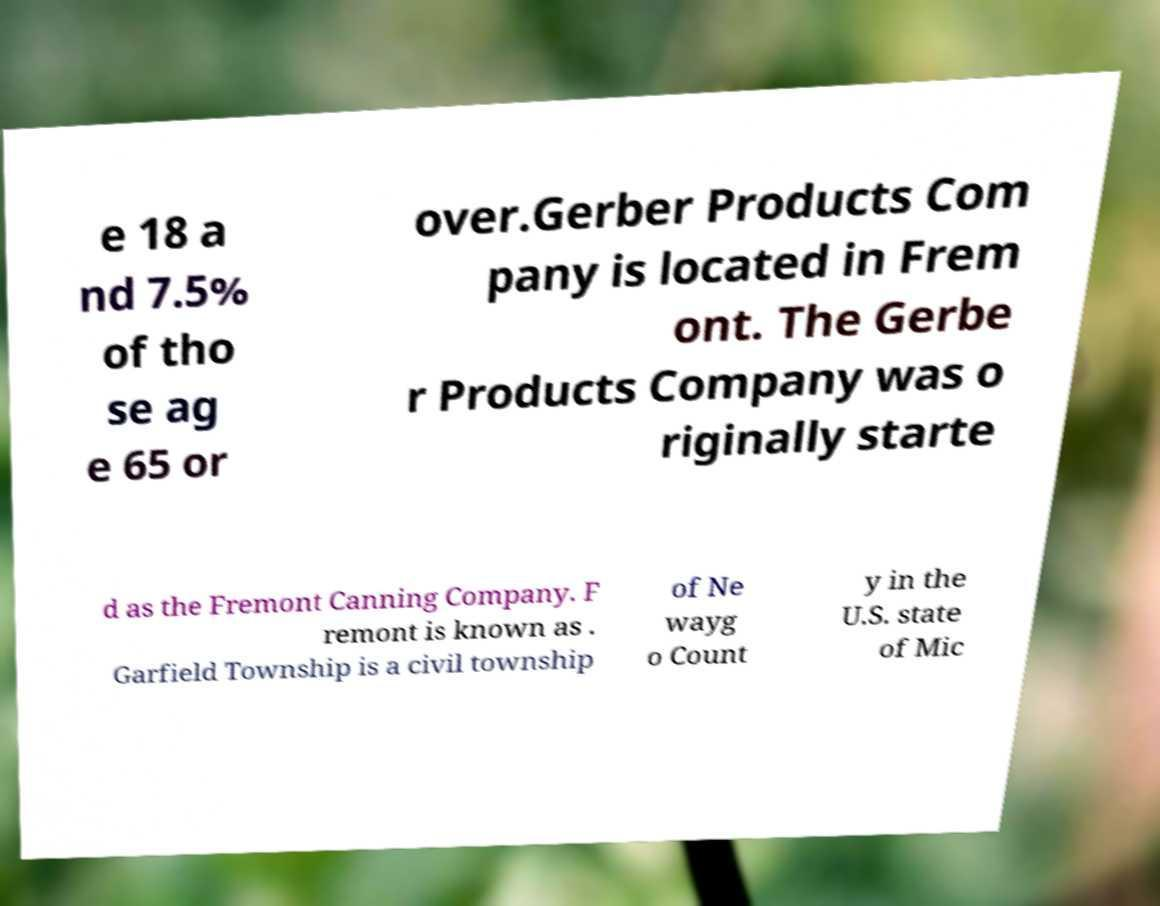Can you read and provide the text displayed in the image?This photo seems to have some interesting text. Can you extract and type it out for me? e 18 a nd 7.5% of tho se ag e 65 or over.Gerber Products Com pany is located in Frem ont. The Gerbe r Products Company was o riginally starte d as the Fremont Canning Company. F remont is known as . Garfield Township is a civil township of Ne wayg o Count y in the U.S. state of Mic 